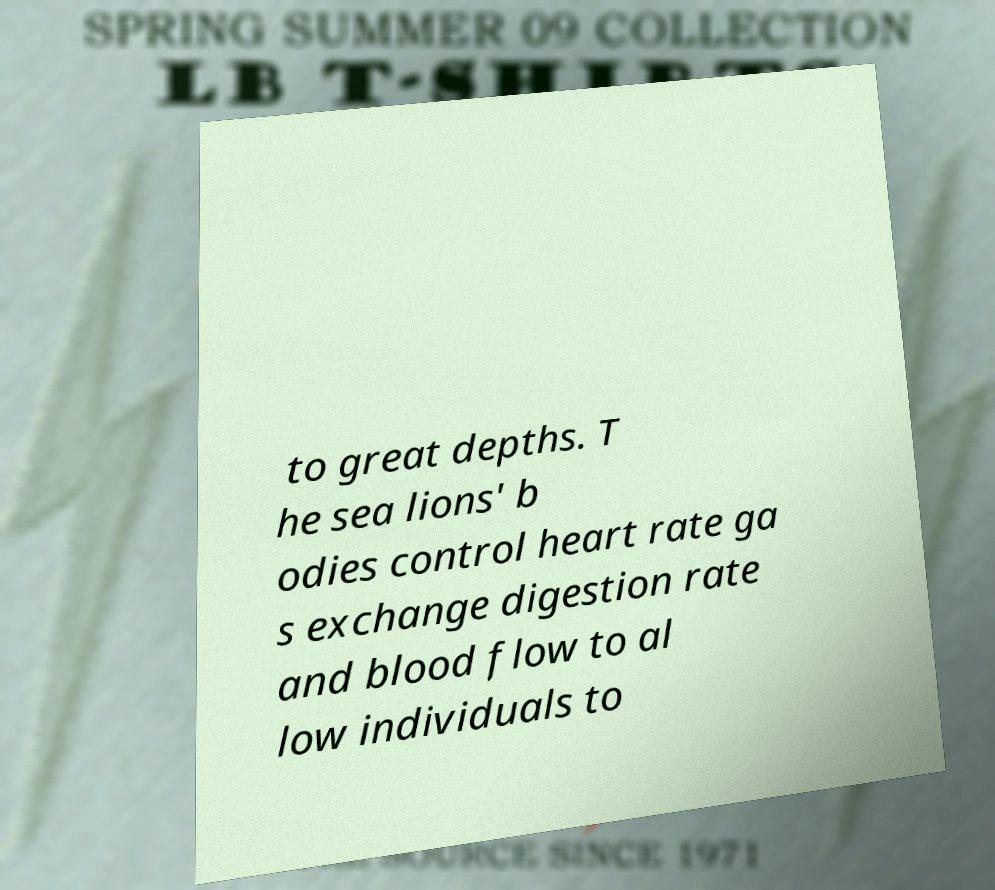I need the written content from this picture converted into text. Can you do that? to great depths. T he sea lions' b odies control heart rate ga s exchange digestion rate and blood flow to al low individuals to 